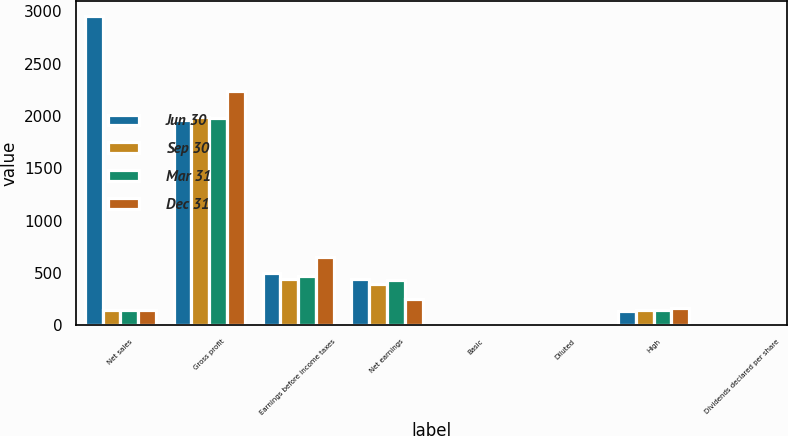<chart> <loc_0><loc_0><loc_500><loc_500><stacked_bar_chart><ecel><fcel>Net sales<fcel>Gross profit<fcel>Earnings before income taxes<fcel>Net earnings<fcel>Basic<fcel>Diluted<fcel>High<fcel>Dividends declared per share<nl><fcel>Jun 30<fcel>2955<fcel>1962<fcel>499<fcel>444<fcel>1.19<fcel>1.17<fcel>133.59<fcel>0.42<nl><fcel>Sep 30<fcel>148.84<fcel>1990<fcel>444<fcel>391<fcel>1.04<fcel>1.03<fcel>145.62<fcel>0.42<nl><fcel>Mar 31<fcel>148.84<fcel>1982<fcel>471<fcel>434<fcel>1.16<fcel>1.14<fcel>148.84<fcel>0.42<nl><fcel>Dec 31<fcel>148.84<fcel>2239<fcel>649<fcel>249<fcel>0.66<fcel>0.66<fcel>160.62<fcel>0.47<nl></chart> 